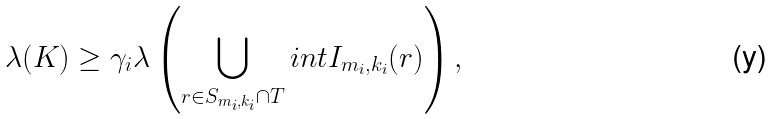Convert formula to latex. <formula><loc_0><loc_0><loc_500><loc_500>\lambda ( K ) \geq \gamma _ { i } \lambda \left ( \bigcup _ { r \in S _ { m _ { i } , k _ { i } } \cap T } i n t I _ { m _ { i } , k _ { i } } ( r ) \right ) ,</formula> 